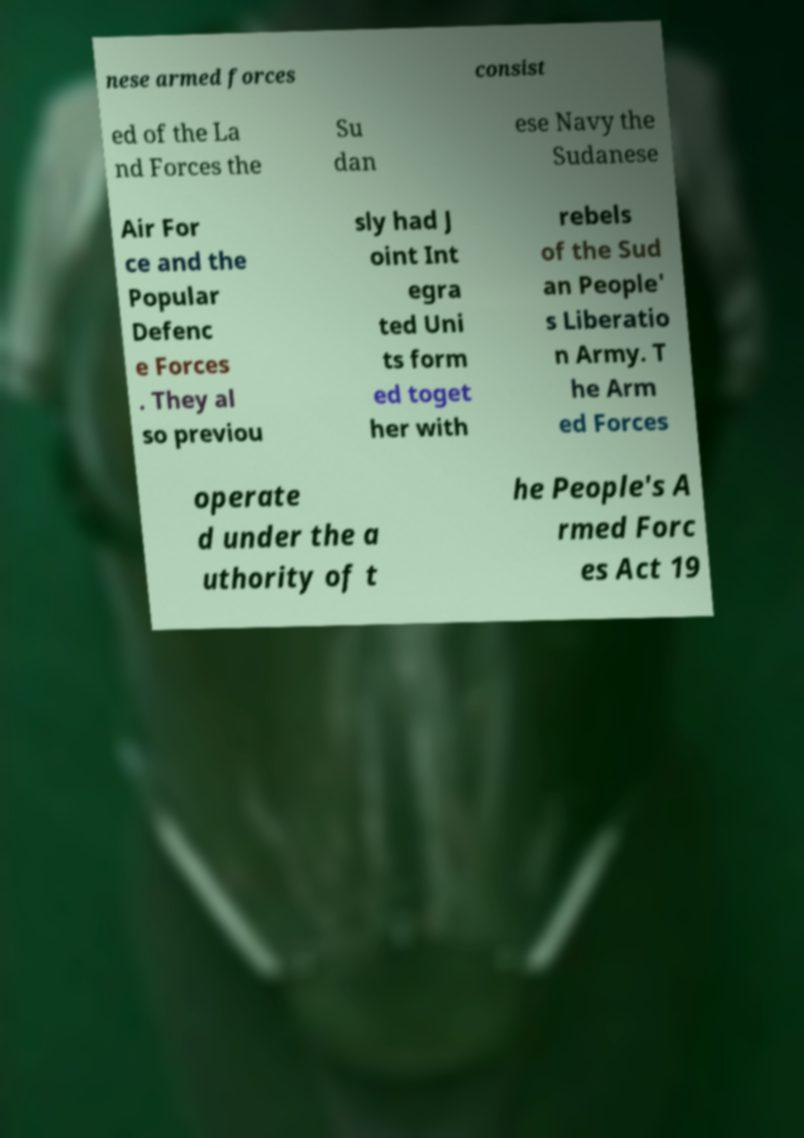Could you assist in decoding the text presented in this image and type it out clearly? nese armed forces consist ed of the La nd Forces the Su dan ese Navy the Sudanese Air For ce and the Popular Defenc e Forces . They al so previou sly had J oint Int egra ted Uni ts form ed toget her with rebels of the Sud an People' s Liberatio n Army. T he Arm ed Forces operate d under the a uthority of t he People's A rmed Forc es Act 19 